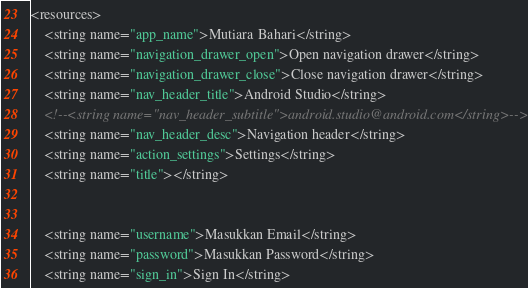Convert code to text. <code><loc_0><loc_0><loc_500><loc_500><_XML_><resources>
	<string name="app_name">Mutiara Bahari</string>
	<string name="navigation_drawer_open">Open navigation drawer</string>
	<string name="navigation_drawer_close">Close navigation drawer</string>
	<string name="nav_header_title">Android Studio</string>
	<!--<string name="nav_header_subtitle">android.studio@android.com</string>-->
	<string name="nav_header_desc">Navigation header</string>
	<string name="action_settings">Settings</string>
	<string name="title"></string>


	<string name="username">Masukkan Email</string>
	<string name="password">Masukkan Password</string>
	<string name="sign_in">Sign In</string></code> 